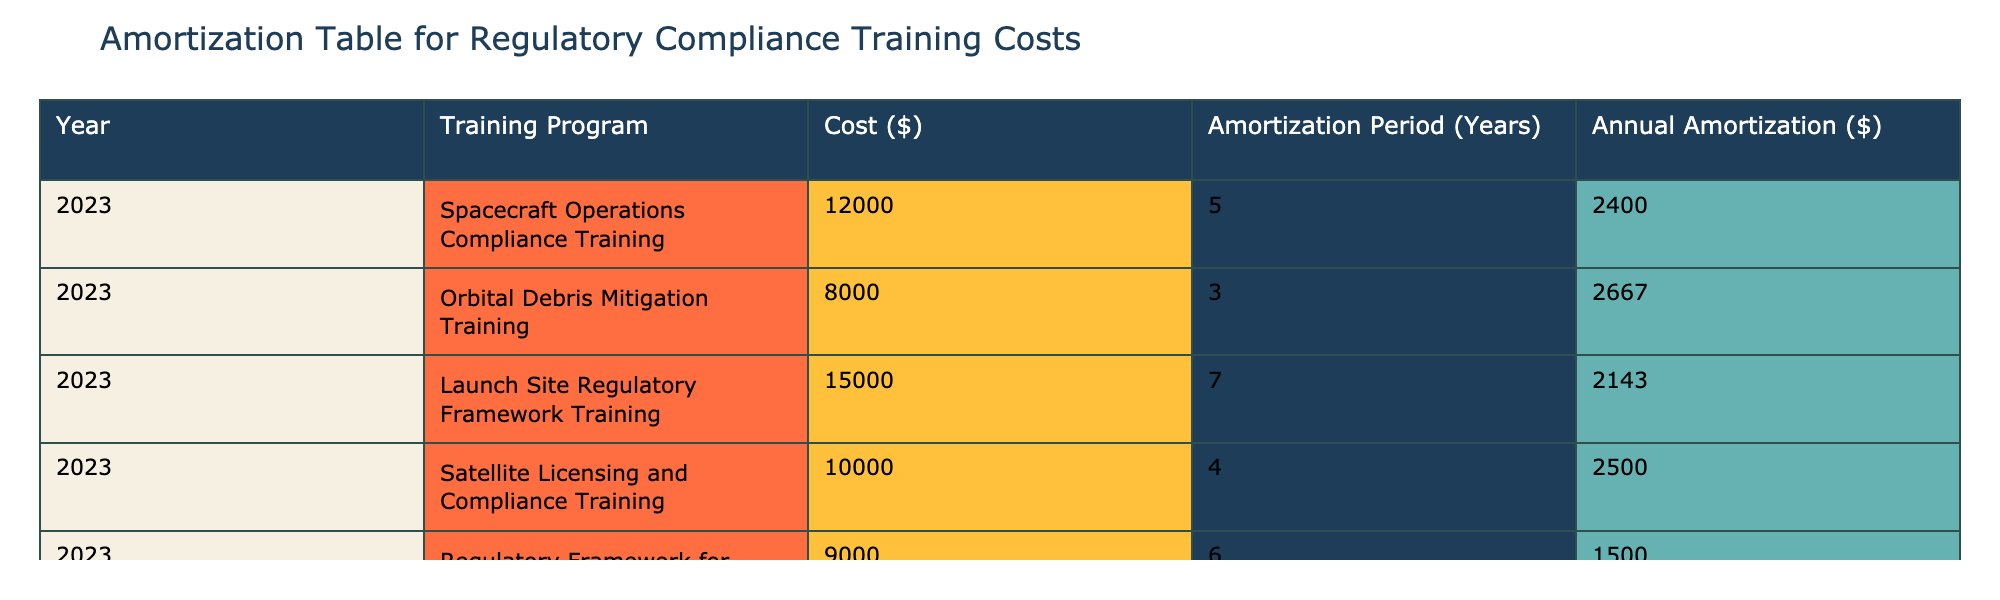What is the total cost of the Spacecraft Operations Compliance Training? The table lists the cost for the Spacecraft Operations Compliance Training as $12,000.
Answer: 12000 How many years is the amortization period for the Launch Site Regulatory Framework Training? The table shows that the amortization period for the Launch Site Regulatory Framework Training is 7 years.
Answer: 7 What is the average annual amortization amount for all training programs? To find the average, sum the annual amortization amounts: (2400 + 2667 + 2143 + 2500 + 1500) = 11210. There are 5 training programs, so the average is 11210/5 = 2242.
Answer: 2242 Is the annual amortization for the Orbital Debris Mitigation Training greater than $2500? The annual amortization for the Orbital Debris Mitigation Training is $2,667, which is greater than $2,500.
Answer: Yes Which training program has the highest annual amortization, and what is that amount? Reviewing the annual amortization amounts shows that the Orbital Debris Mitigation Training has the highest at $2,667.
Answer: Orbital Debris Mitigation Training, 2667 What is the combined cost of the Satellite Licensing and Compliance Training and the Regulatory Framework for Private Spaceflight training programs? The costs are $10,000 for the Satellite Licensing and Compliance Training and $9,000 for the Regulatory Framework for Private Spaceflight. Adding these together: 10000 + 9000 = 19000.
Answer: 19000 What is the difference in annual amortization between the Launch Site Regulatory Framework Training and the Regulatory Framework for Private Spaceflight? The table indicates that the annual amortization is $2,143 for Launch Site Regulatory Framework Training and $1,500 for Regulatory Framework for Private Spaceflight. The difference is 2143 - 1500 = 643.
Answer: 643 Is the cost of the Spacecraft Operations Compliance Training less than the average cost of all training programs? The average cost can be calculated by summing all costs: 12000 + 8000 + 15000 + 10000 + 9000 = 62000, and dividing by 5 gives an average of 12400. The Spacecraft Operations Compliance Training cost is $12,000, which is less than this average.
Answer: Yes 